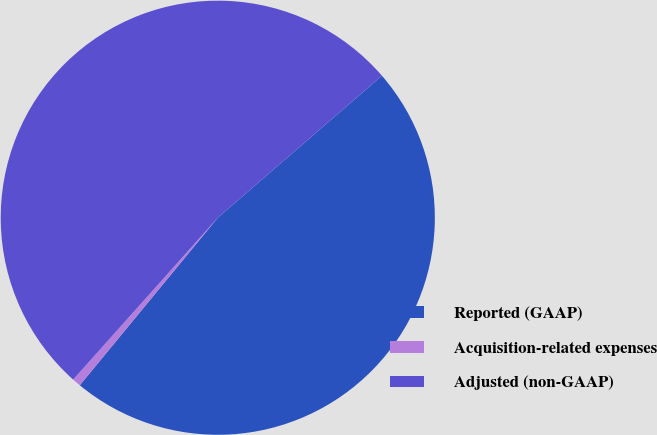Convert chart. <chart><loc_0><loc_0><loc_500><loc_500><pie_chart><fcel>Reported (GAAP)<fcel>Acquisition-related expenses<fcel>Adjusted (non-GAAP)<nl><fcel>47.31%<fcel>0.64%<fcel>52.04%<nl></chart> 